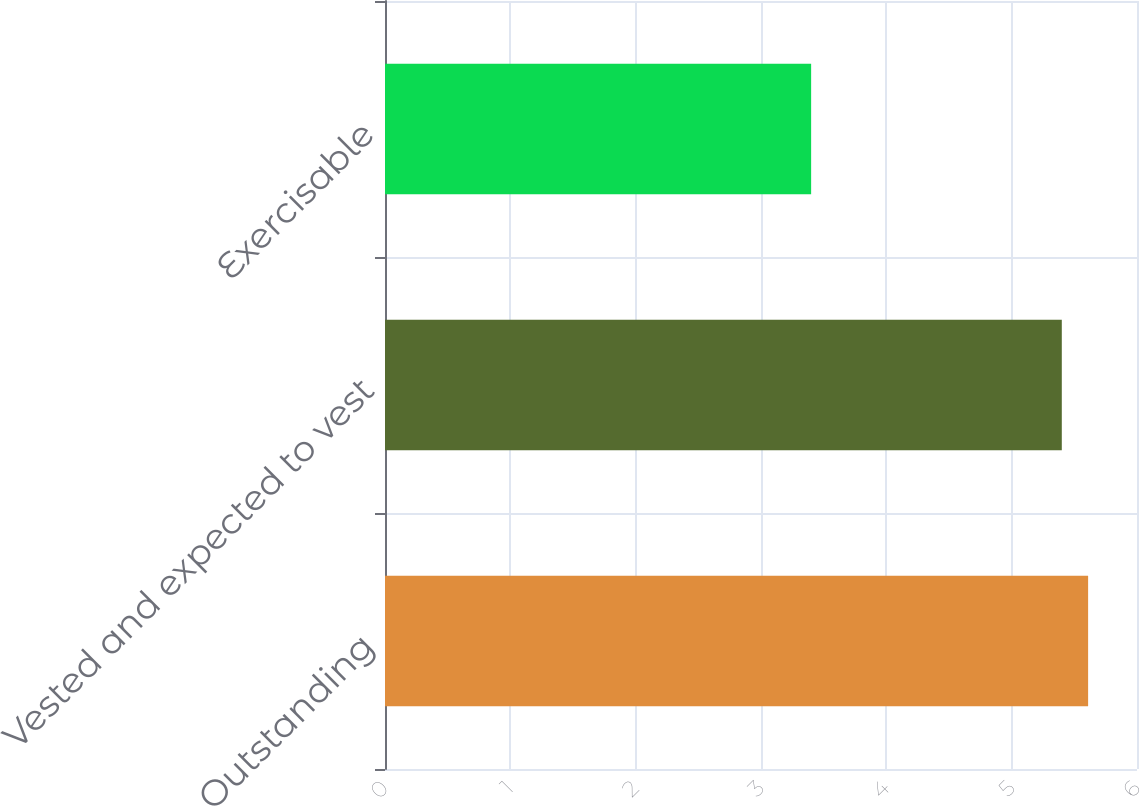Convert chart to OTSL. <chart><loc_0><loc_0><loc_500><loc_500><bar_chart><fcel>Outstanding<fcel>Vested and expected to vest<fcel>Exercisable<nl><fcel>5.61<fcel>5.4<fcel>3.4<nl></chart> 